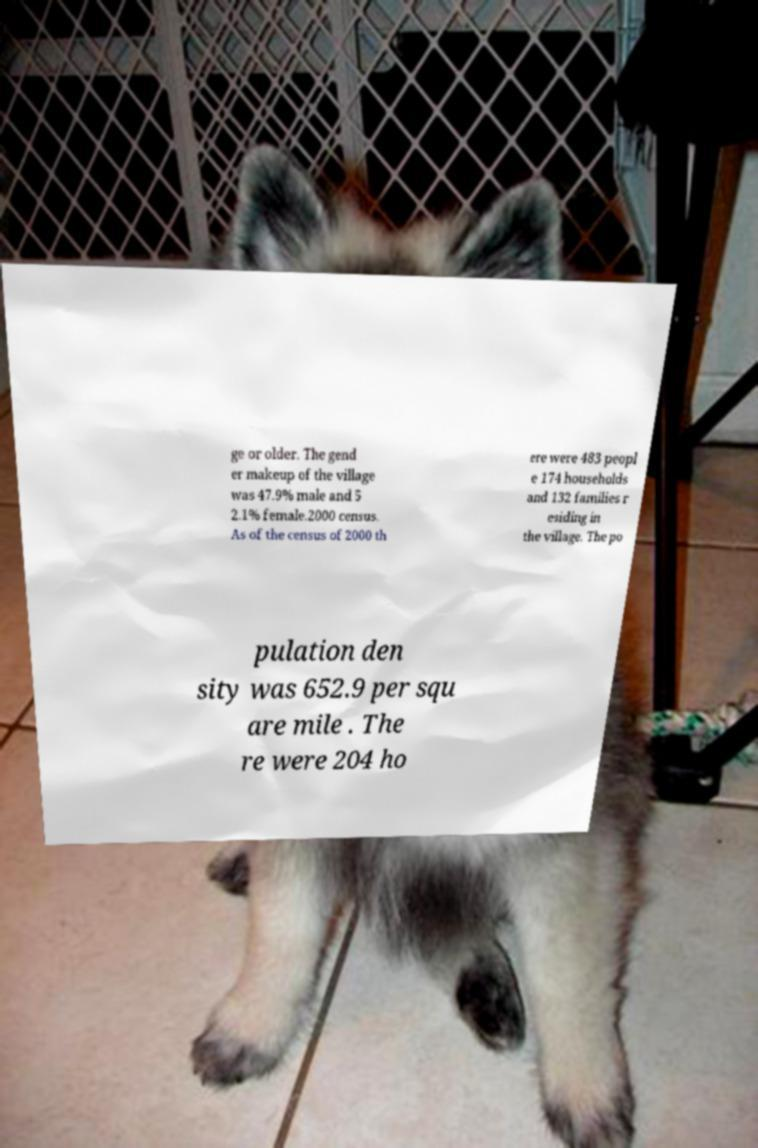Please identify and transcribe the text found in this image. ge or older. The gend er makeup of the village was 47.9% male and 5 2.1% female.2000 census. As of the census of 2000 th ere were 483 peopl e 174 households and 132 families r esiding in the village. The po pulation den sity was 652.9 per squ are mile . The re were 204 ho 